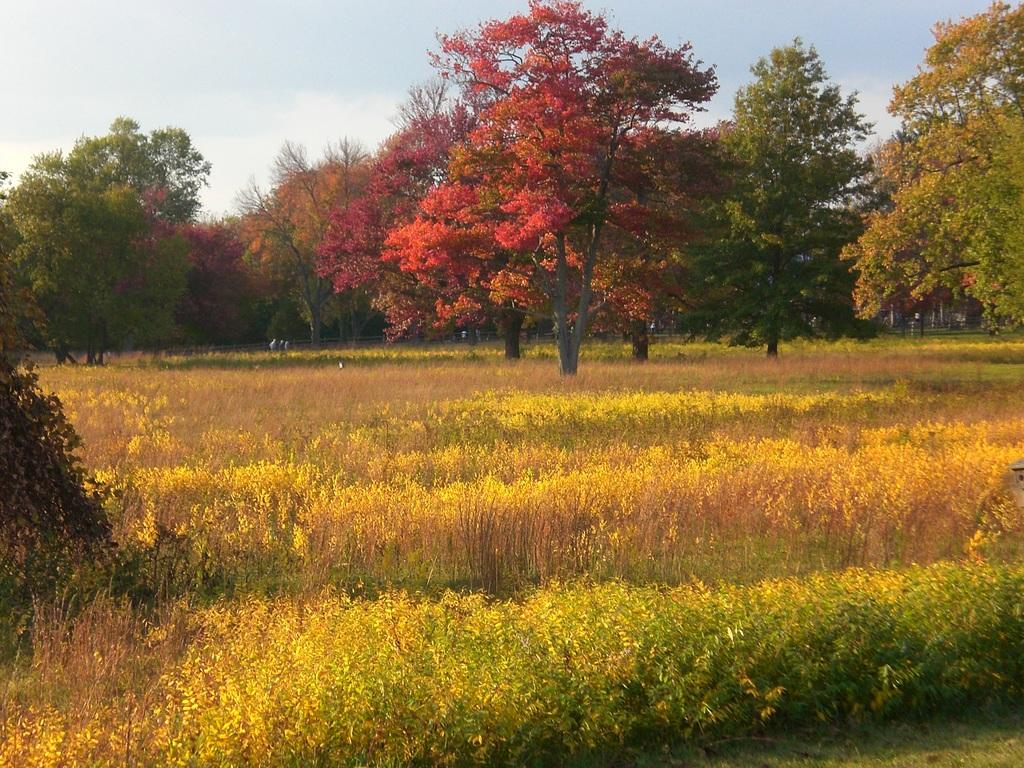What type of vegetation can be seen in the image? There is grass, plants, and trees in the image. What else is present in the image besides vegetation? There are objects in the image. What can be seen in the sky in the image? The sky is visible in the image. What language is being spoken by the plants in the image? There are no plants or any other living organisms capable of speech in the image. 